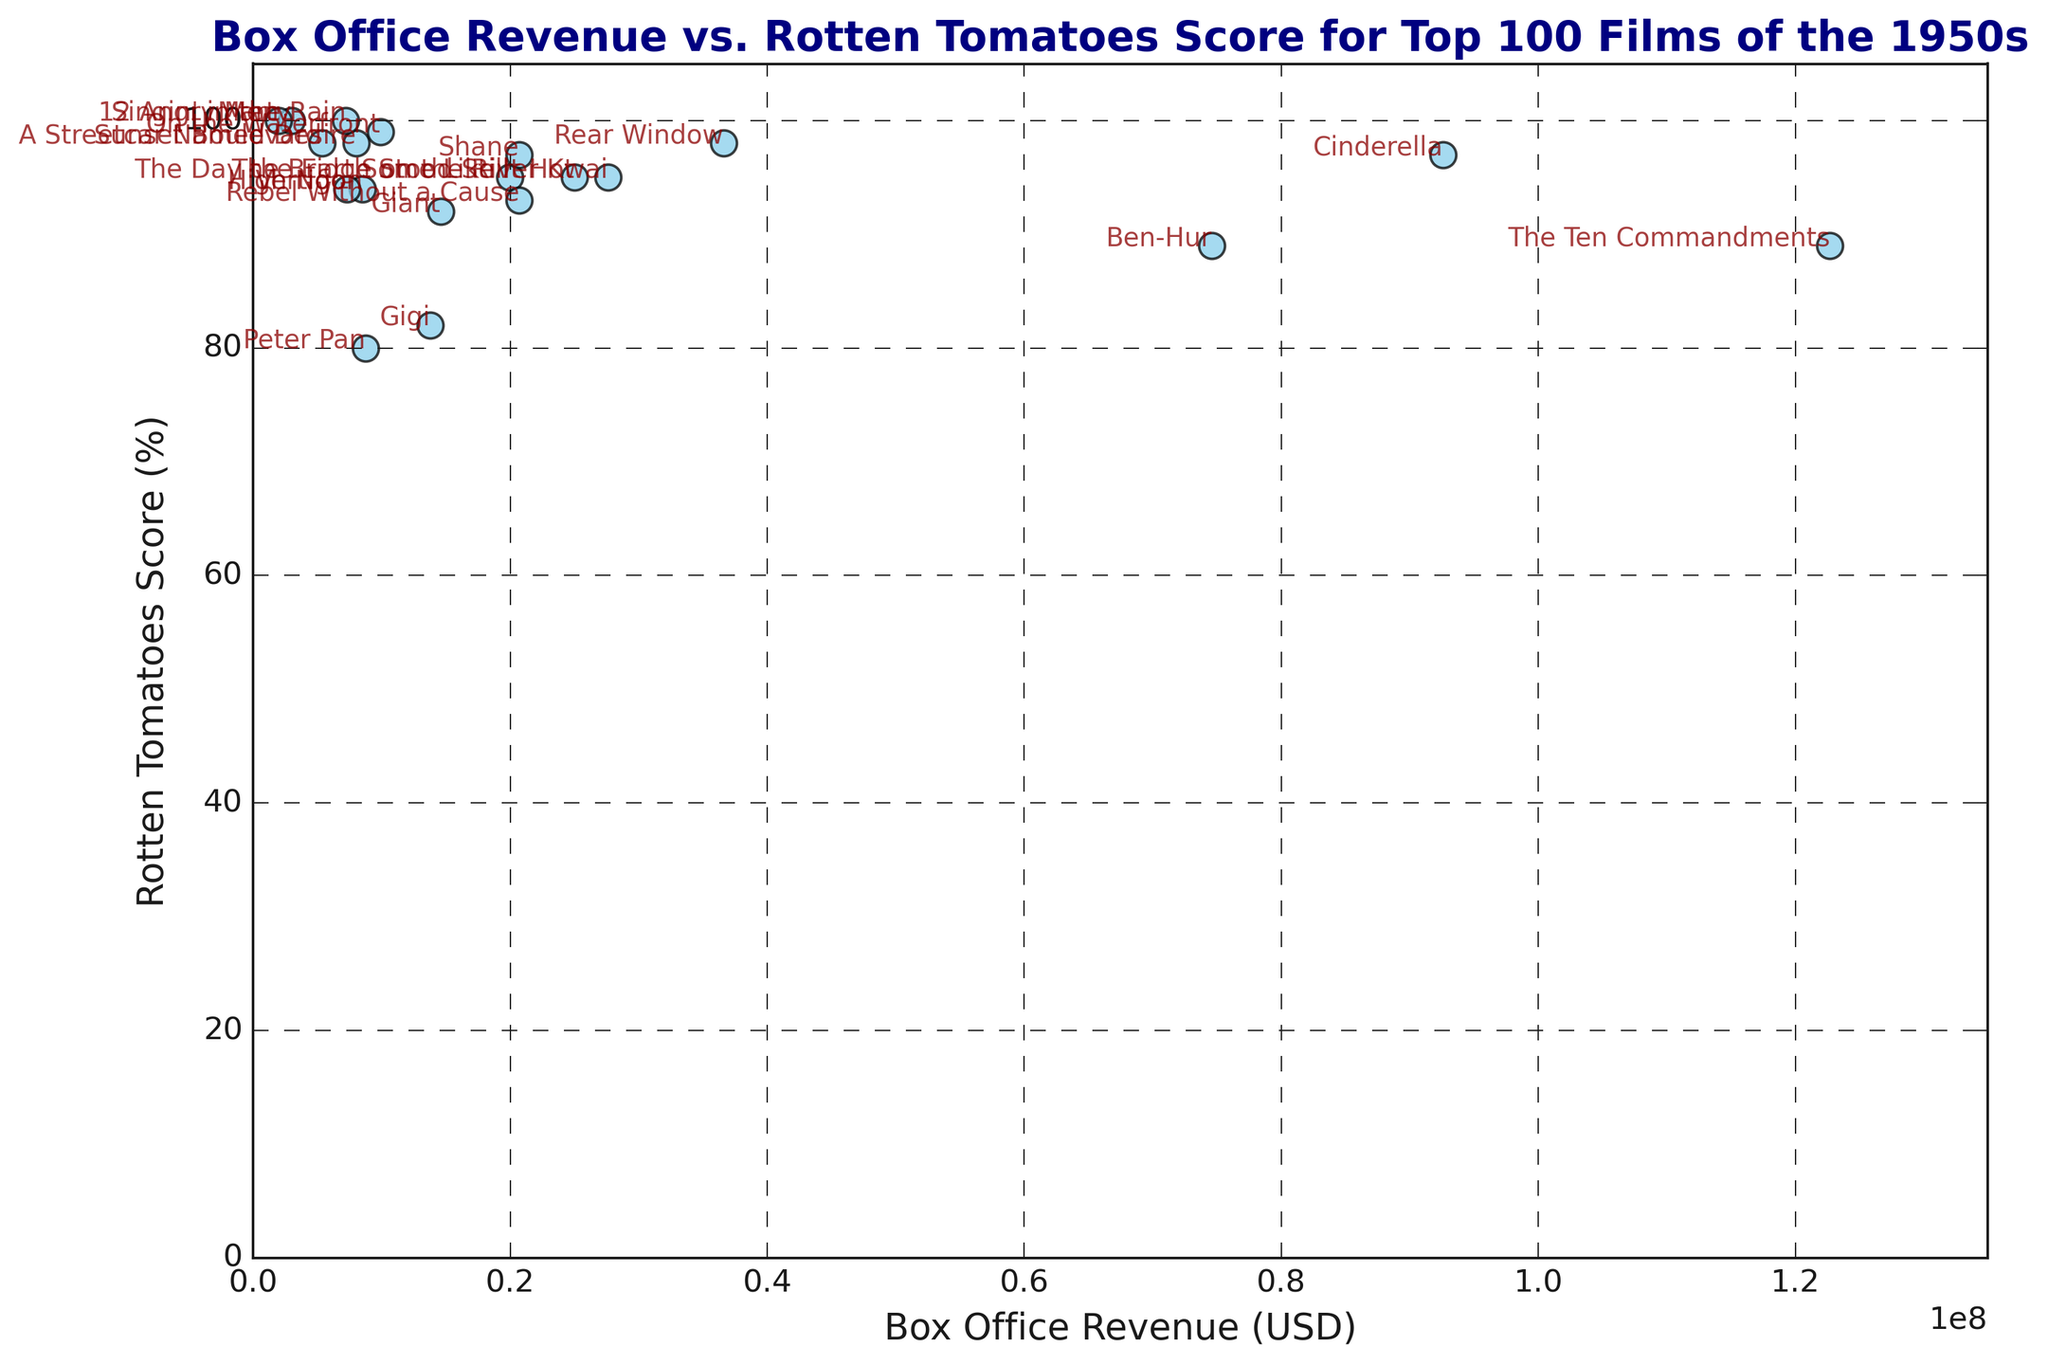What film has the highest Rotten Tomatoes Score? Look for the data point that reaches the topmost part of the y-axis. "Singin' in the Rain," "12 Angry Men," and "Marty" all have a Rotten Tomatoes Score of 100.
Answer: "Singin' in the Rain," "12 Angry Men," and "Marty" Which film had the highest box office revenue? Identify the point furthest to the right on the x-axis. This is "The Ten Commandments" with a revenue of $122.7 million.
Answer: "The Ten Commandments" Which film has the lowest Rotten Tomatoes Score? Look for the data point closest to the bottom of the y-axis. "Peter Pan" has the lowest score at 80.
Answer: "Peter Pan" Which films are both critically acclaimed (Rotten Tomatoes Score 95+) and financially successful (Box Office Revenue $20 million+)? Look at data points with scores 95 and higher and check for their box office revenue. Films matching this are "Rear Window," "Rebel Without a Cause," "Shane," and "Some Like It Hot."
Answer: "Rear Window," "Rebel Without a Cause," "Shane," "Some Like It Hot" What is the average Rotten Tomatoes Score for films with box office revenue above $20 million? Identify films with box office revenue above $20 million: "The Ten Commandments," "Rear Window," "Rebel Without a Cause," "The Bridge on the River Kwai," "Some Like It Hot," "Ben-Hur." Add their scores (89, 98, 93, 95, 95, 89) and divide by the number of films (6).
Answer: (89+98+93+95+95+89)/6 = 93.17 Which film has the largest difference between box office revenue and Rotten Tomatoes Score? Calculate the difference for each film, then find the maximum. "The Ten Commandments" has the largest difference, with a $122.7M revenue and an 89% score, differing by 122.7-89=33.7.
Answer: "The Ten Commandments" How many films have both a Rotten Tomatoes Score of 100 and a box office revenue above $5 million? Check films with a score of 100 and their revenue. "Singin' in the Rain" ($7.22M) and "Marty" ($3M). Only "Singin' in the Rain" matches both conditions.
Answer: 1 film (Singin' in the Rain) Which year had the most films with Rotten Tomatoes Scores above 95? Gather years of films with scores above 95: 1950 (2), 1951 (2), 1952 (1), 1953 (1), 1954 (2), 1955 (1), 1957 (2), 1958 (1), 1959 (2).
Answer: 1950, 1951, 1954, 1957, and 1959 (2 each) Among the films with a Rotten Tomatoes score of 100, which one had the lowest box office revenue? List films with a score of 100: "Singin' in the Rain," "Marty," "12 Angry Men." Identify the one with the lowest revenue. "12 Angry Men" has $2M.
Answer: "12 Angry Men" Which film has a similar Rotten Tomatoes Score to "Ben-Hur" but a much lower box office revenue? "Ben-Hur" has a score of 89. Identify films with close scores and lower revenue: "The Ten Commandments" (89) has higher revenue, "Gigi" (82). It seems "The Ten Commandments" has similar RT but higher revenue, making it stand out nonetheless.
Answer: Despite revenue, no exact match with much lower revenue 